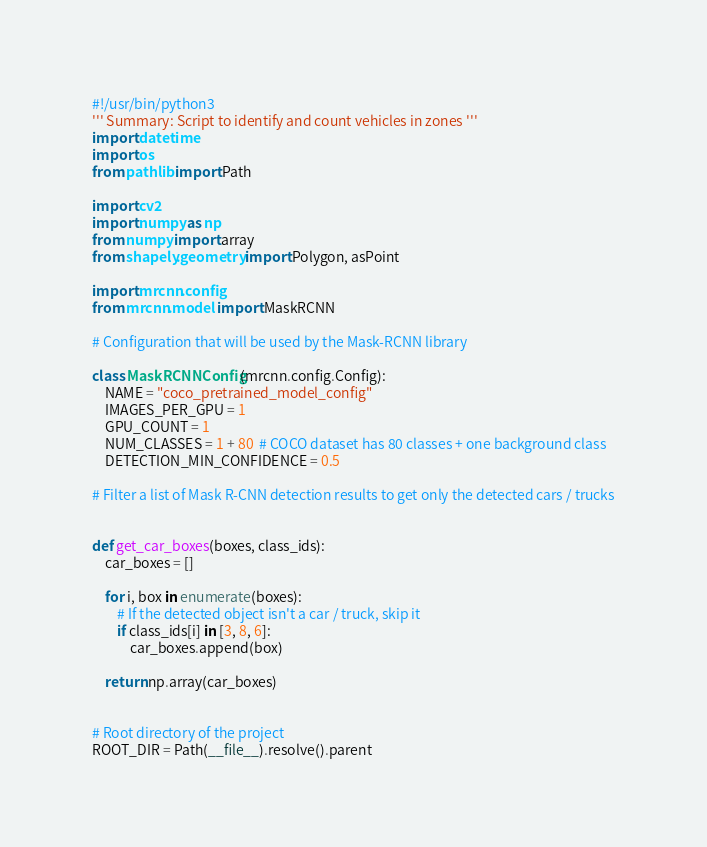<code> <loc_0><loc_0><loc_500><loc_500><_Python_>#!/usr/bin/python3
''' Summary: Script to identify and count vehicles in zones '''
import datetime
import os
from pathlib import Path

import cv2
import numpy as np
from numpy import array
from shapely.geometry import Polygon, asPoint

import mrcnn.config
from mrcnn.model import MaskRCNN

# Configuration that will be used by the Mask-RCNN library

class MaskRCNNConfig(mrcnn.config.Config):
    NAME = "coco_pretrained_model_config"
    IMAGES_PER_GPU = 1
    GPU_COUNT = 1
    NUM_CLASSES = 1 + 80  # COCO dataset has 80 classes + one background class
    DETECTION_MIN_CONFIDENCE = 0.5

# Filter a list of Mask R-CNN detection results to get only the detected cars / trucks


def get_car_boxes(boxes, class_ids):
    car_boxes = []

    for i, box in enumerate(boxes):
        # If the detected object isn't a car / truck, skip it
        if class_ids[i] in [3, 8, 6]:
            car_boxes.append(box)

    return np.array(car_boxes)


# Root directory of the project
ROOT_DIR = Path(__file__).resolve().parent
</code> 